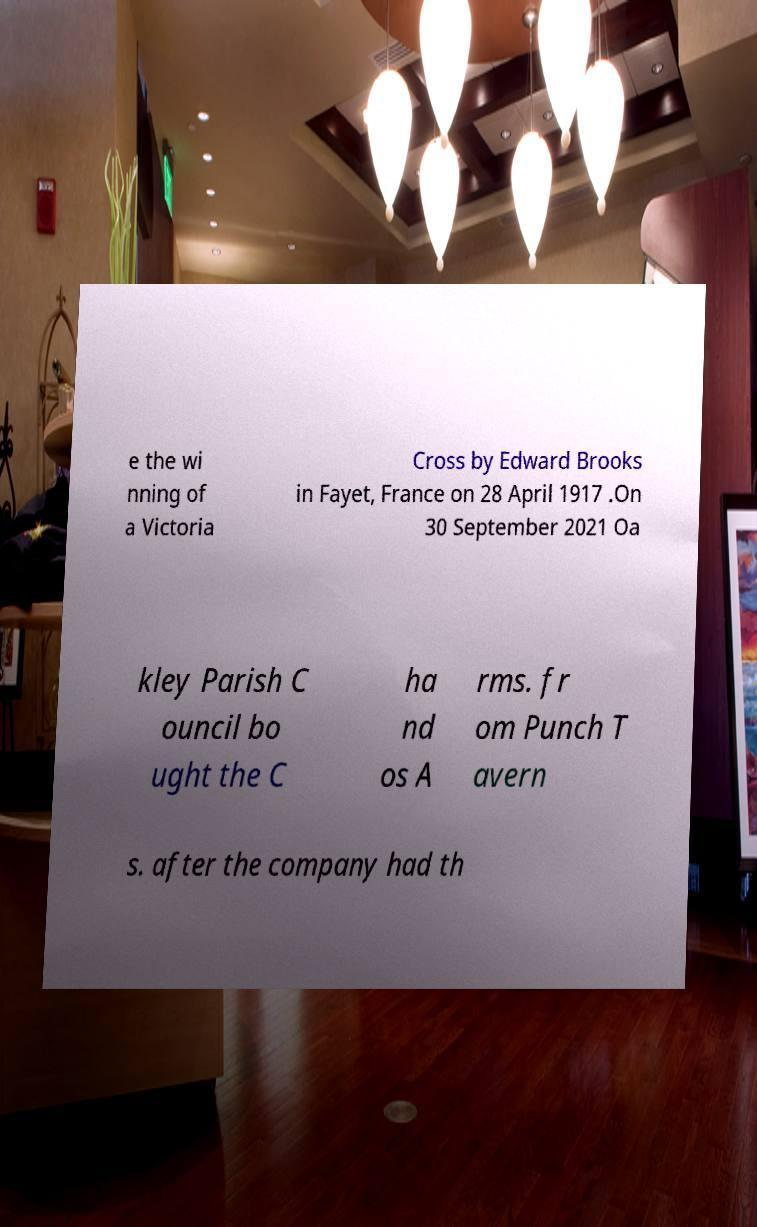Please identify and transcribe the text found in this image. e the wi nning of a Victoria Cross by Edward Brooks in Fayet, France on 28 April 1917 .On 30 September 2021 Oa kley Parish C ouncil bo ught the C ha nd os A rms. fr om Punch T avern s. after the company had th 